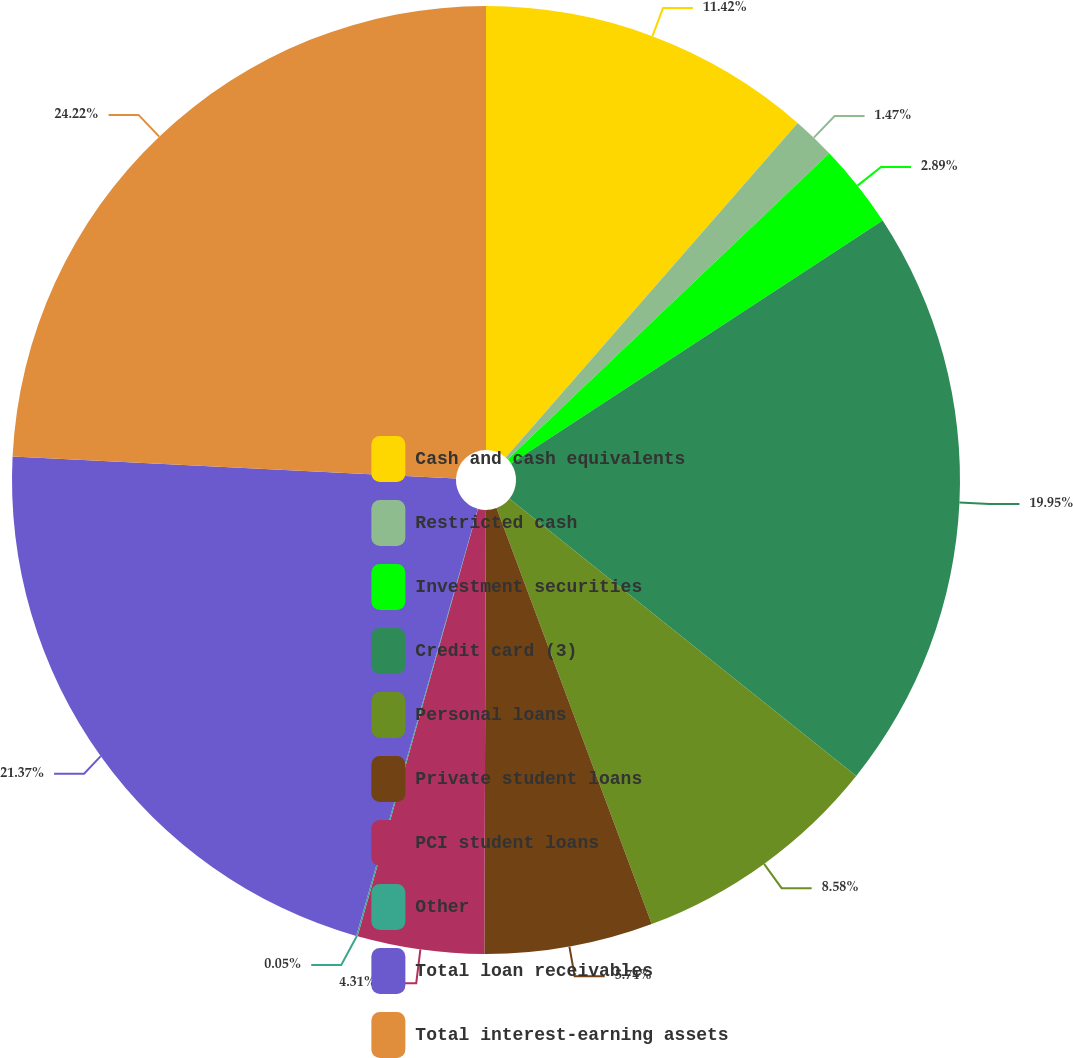<chart> <loc_0><loc_0><loc_500><loc_500><pie_chart><fcel>Cash and cash equivalents<fcel>Restricted cash<fcel>Investment securities<fcel>Credit card (3)<fcel>Personal loans<fcel>Private student loans<fcel>PCI student loans<fcel>Other<fcel>Total loan receivables<fcel>Total interest-earning assets<nl><fcel>11.42%<fcel>1.47%<fcel>2.89%<fcel>19.95%<fcel>8.58%<fcel>5.74%<fcel>4.31%<fcel>0.05%<fcel>21.37%<fcel>24.21%<nl></chart> 